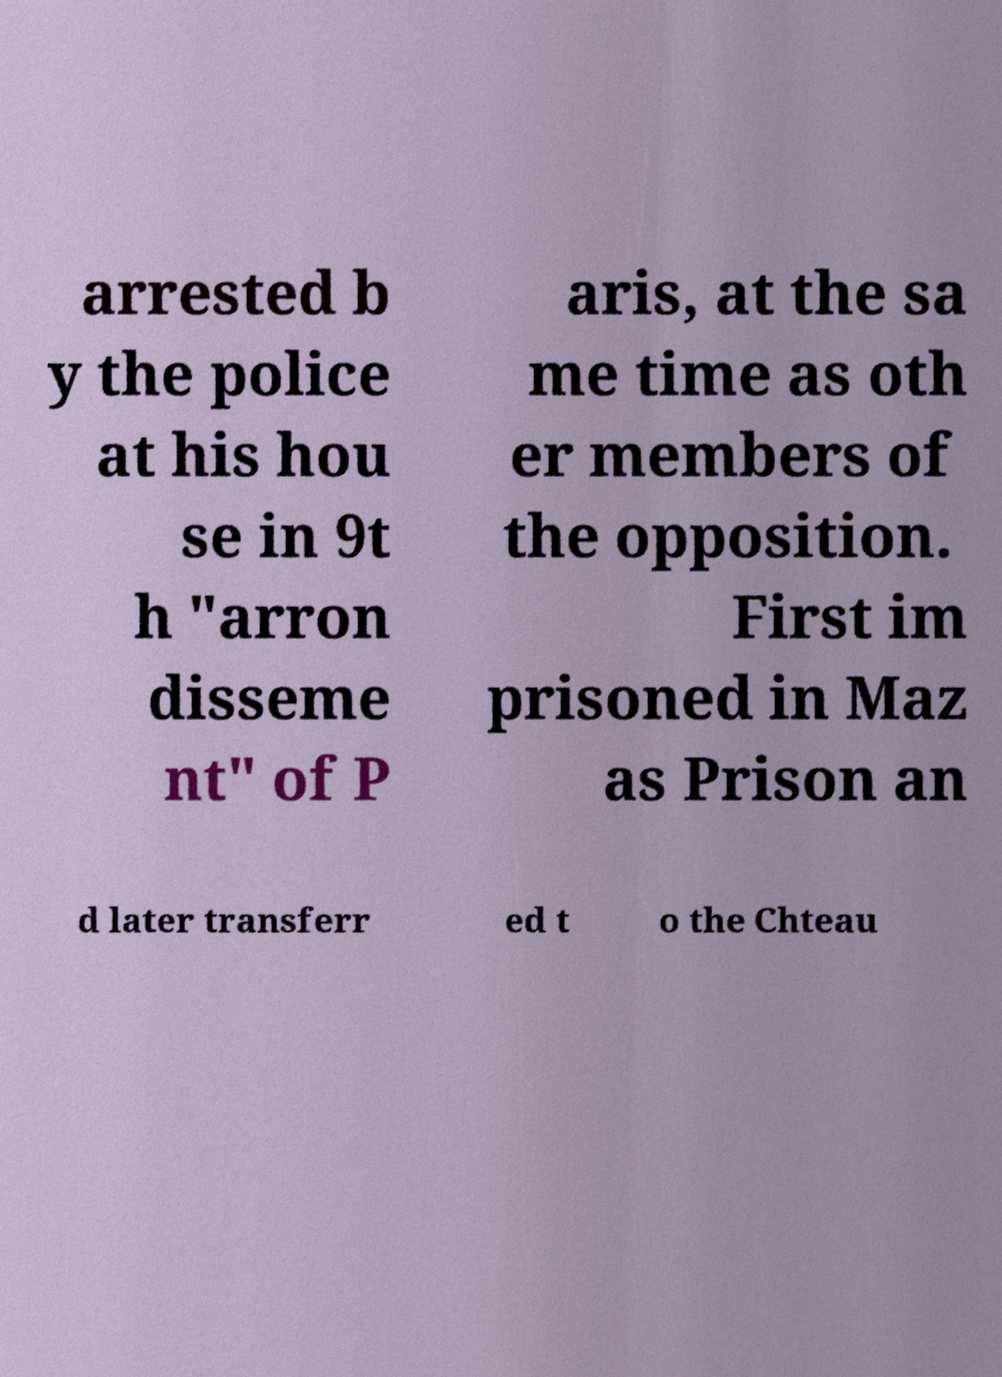What messages or text are displayed in this image? I need them in a readable, typed format. arrested b y the police at his hou se in 9t h "arron disseme nt" of P aris, at the sa me time as oth er members of the opposition. First im prisoned in Maz as Prison an d later transferr ed t o the Chteau 